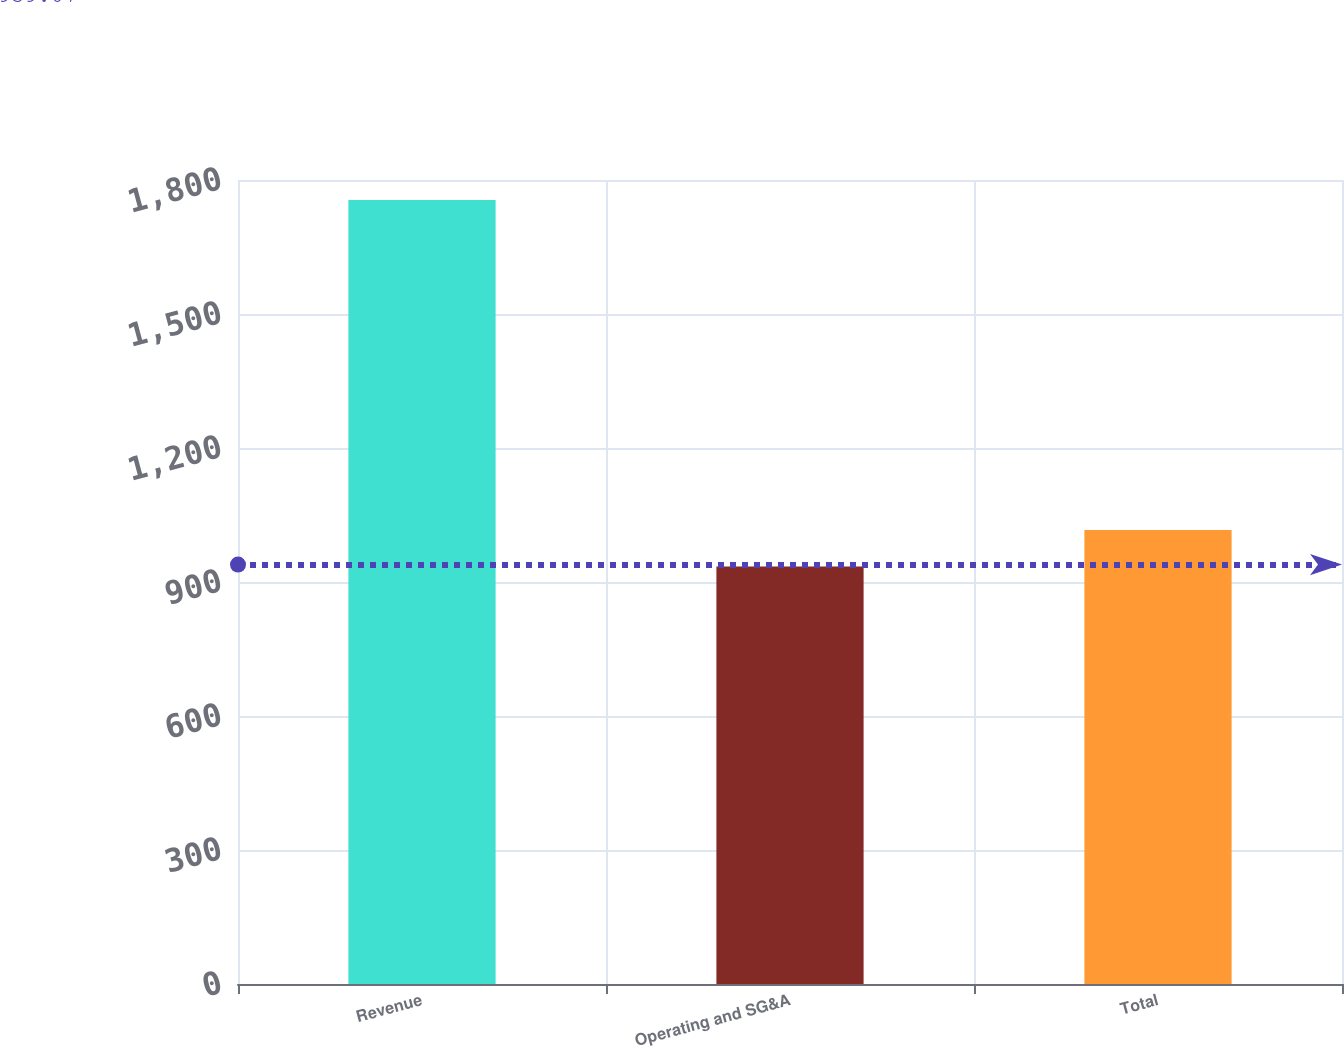<chart> <loc_0><loc_0><loc_500><loc_500><bar_chart><fcel>Revenue<fcel>Operating and SG&A<fcel>Total<nl><fcel>1755.4<fcel>934.6<fcel>1016.68<nl></chart> 